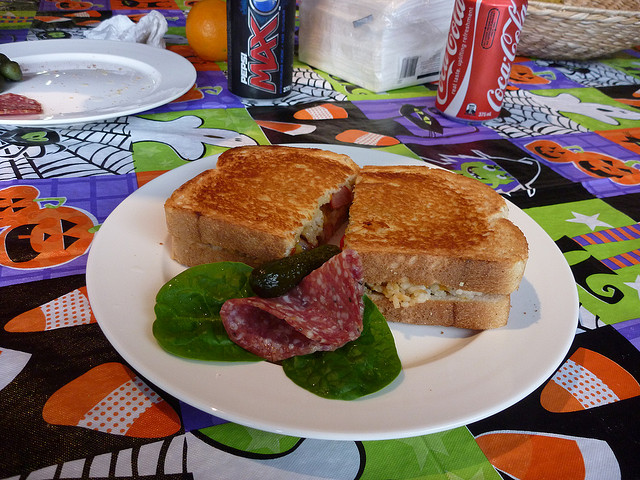Read and extract the text from this image. MAX Coca Coca Cola 